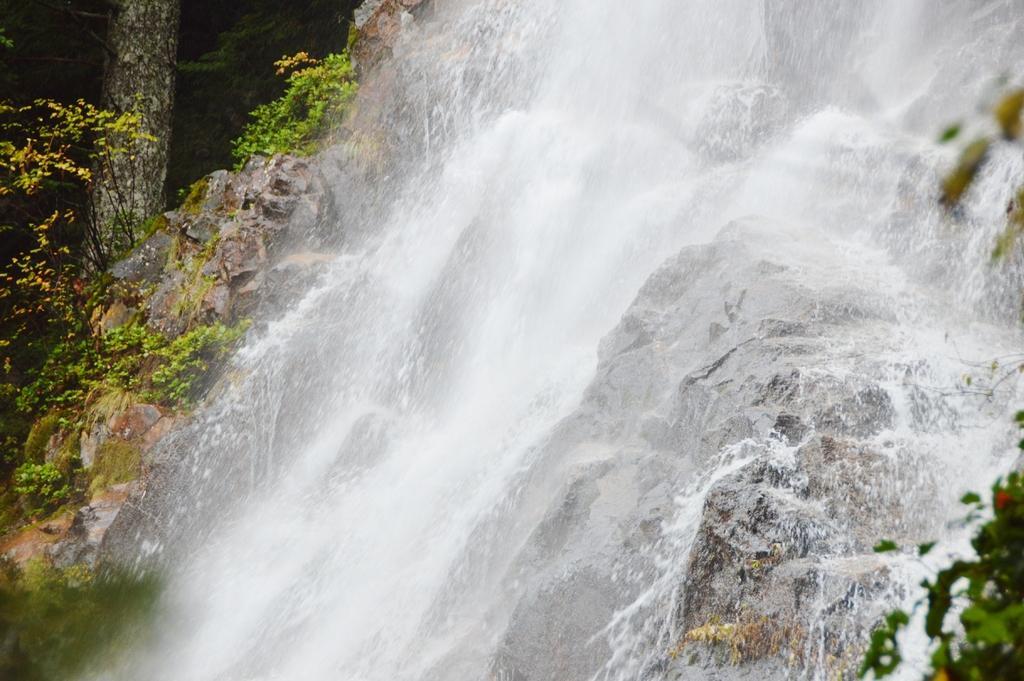Describe this image in one or two sentences. In this image we can see a waterfall. At the bottom there are rocks. In the background there are trees. 